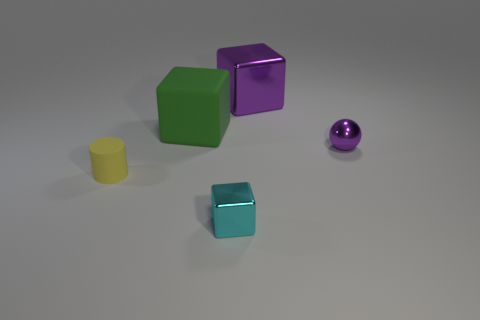Add 2 green things. How many objects exist? 7 Subtract all spheres. How many objects are left? 4 Add 1 tiny purple shiny balls. How many tiny purple shiny balls are left? 2 Add 1 tiny purple metallic things. How many tiny purple metallic things exist? 2 Subtract 0 blue cubes. How many objects are left? 5 Subtract all brown rubber cubes. Subtract all yellow rubber cylinders. How many objects are left? 4 